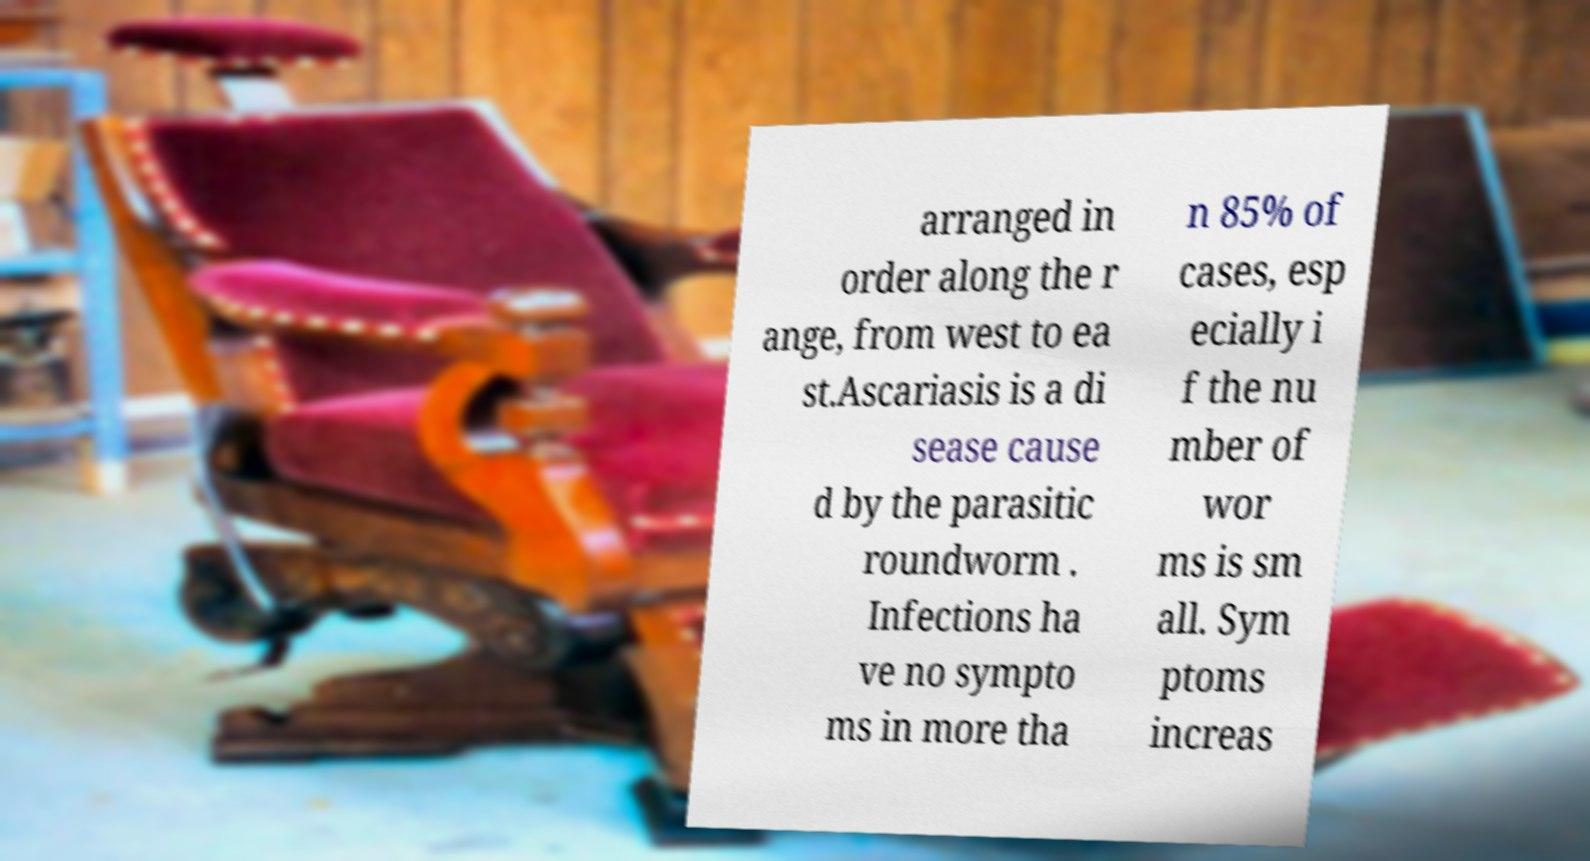Can you read and provide the text displayed in the image?This photo seems to have some interesting text. Can you extract and type it out for me? arranged in order along the r ange, from west to ea st.Ascariasis is a di sease cause d by the parasitic roundworm . Infections ha ve no sympto ms in more tha n 85% of cases, esp ecially i f the nu mber of wor ms is sm all. Sym ptoms increas 